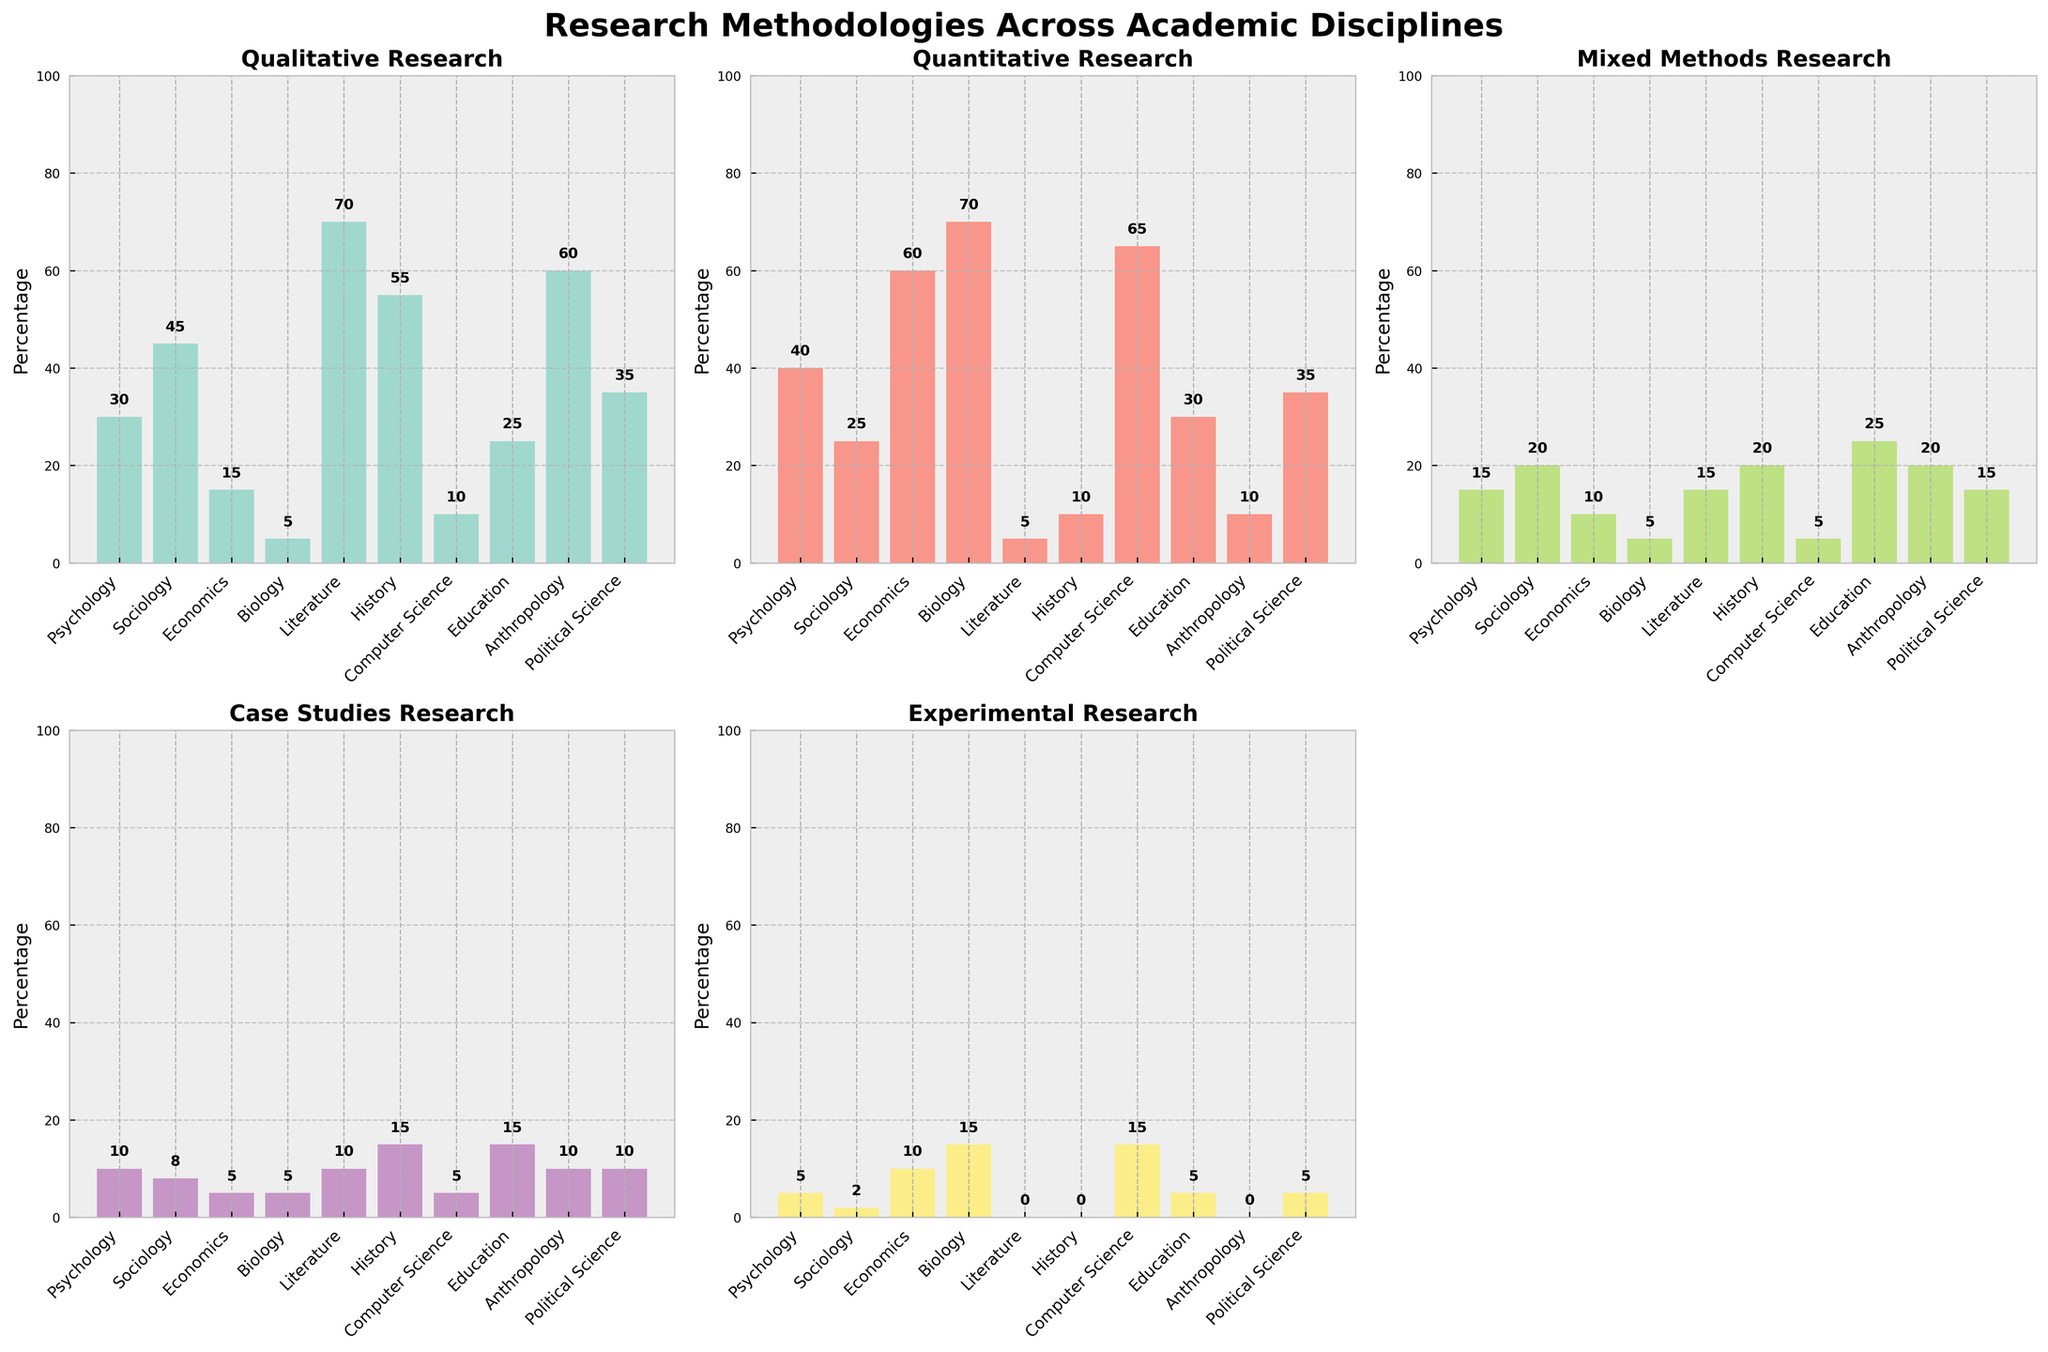Which discipline uses Qualitative research the most? The bar for Qualitative research is the highest for Literature, at 70%.
Answer: Literature Which research method is most frequently used in Biology? The bar for Quantitative research is the highest for Biology, at 70%.
Answer: Quantitative How does the usage of Experimental methods compare between Economics and Computer Science? Both Economics and Computer Science have a 15% usage rate for Experimental methods, shown by the height of the bar in their respective subplots.
Answer: They are equal Which discipline shows the greatest balance among all research methodologies? Education has the highest mixed methods percentage at 25%, and relatively balanced percentages in other categories (25% in Qualitative, 30% in Quantitative, 15% in Case Studies, and 5% in Experimental).
Answer: Education What is the sum of the percentages for Case Studies and Experimental methods in Psychology? In Psychology, the percentage for Case Studies is 10% and for Experimental methods is 5%. Adding these together gives 10% + 5% = 15%.
Answer: 15% Which methodology is used least frequently in Political Science? The Experimental method has the lowest percentage in Political Science at 5%, shown by the smallest bar in its subplot.
Answer: Experimental Is there any discipline that doesn't use Experimental methods at all? Both Literature and History have a 0% usage for Experimental methods, indicated by the absence of a bar in Experimental Research subplot for these disciplines.
Answer: Literature and History What is the average percentage of Qualitative research for Psychology, Sociology, and Anthropology? The percentages for Qualitative research are 30% for Psychology, 45% for Sociology, and 60% for Anthropology. The average is (30 + 45 + 60) / 3 = 45%.
Answer: 45% Which has a greater percentage in Education, Qualitative or Quantitative research? In Education, Qualitative research has a percentage of 25%, while Quantitative research has a percentage of 30%. Therefore, Quantitative research is greater.
Answer: Quantitative What is the difference in the usage percentage of Experimental methods between Psychology and Economics? In Psychology, the percentage for Experimental methods is 5%, whereas in Economics it is 10%. The difference is 10% - 5% = 5%.
Answer: 5% 